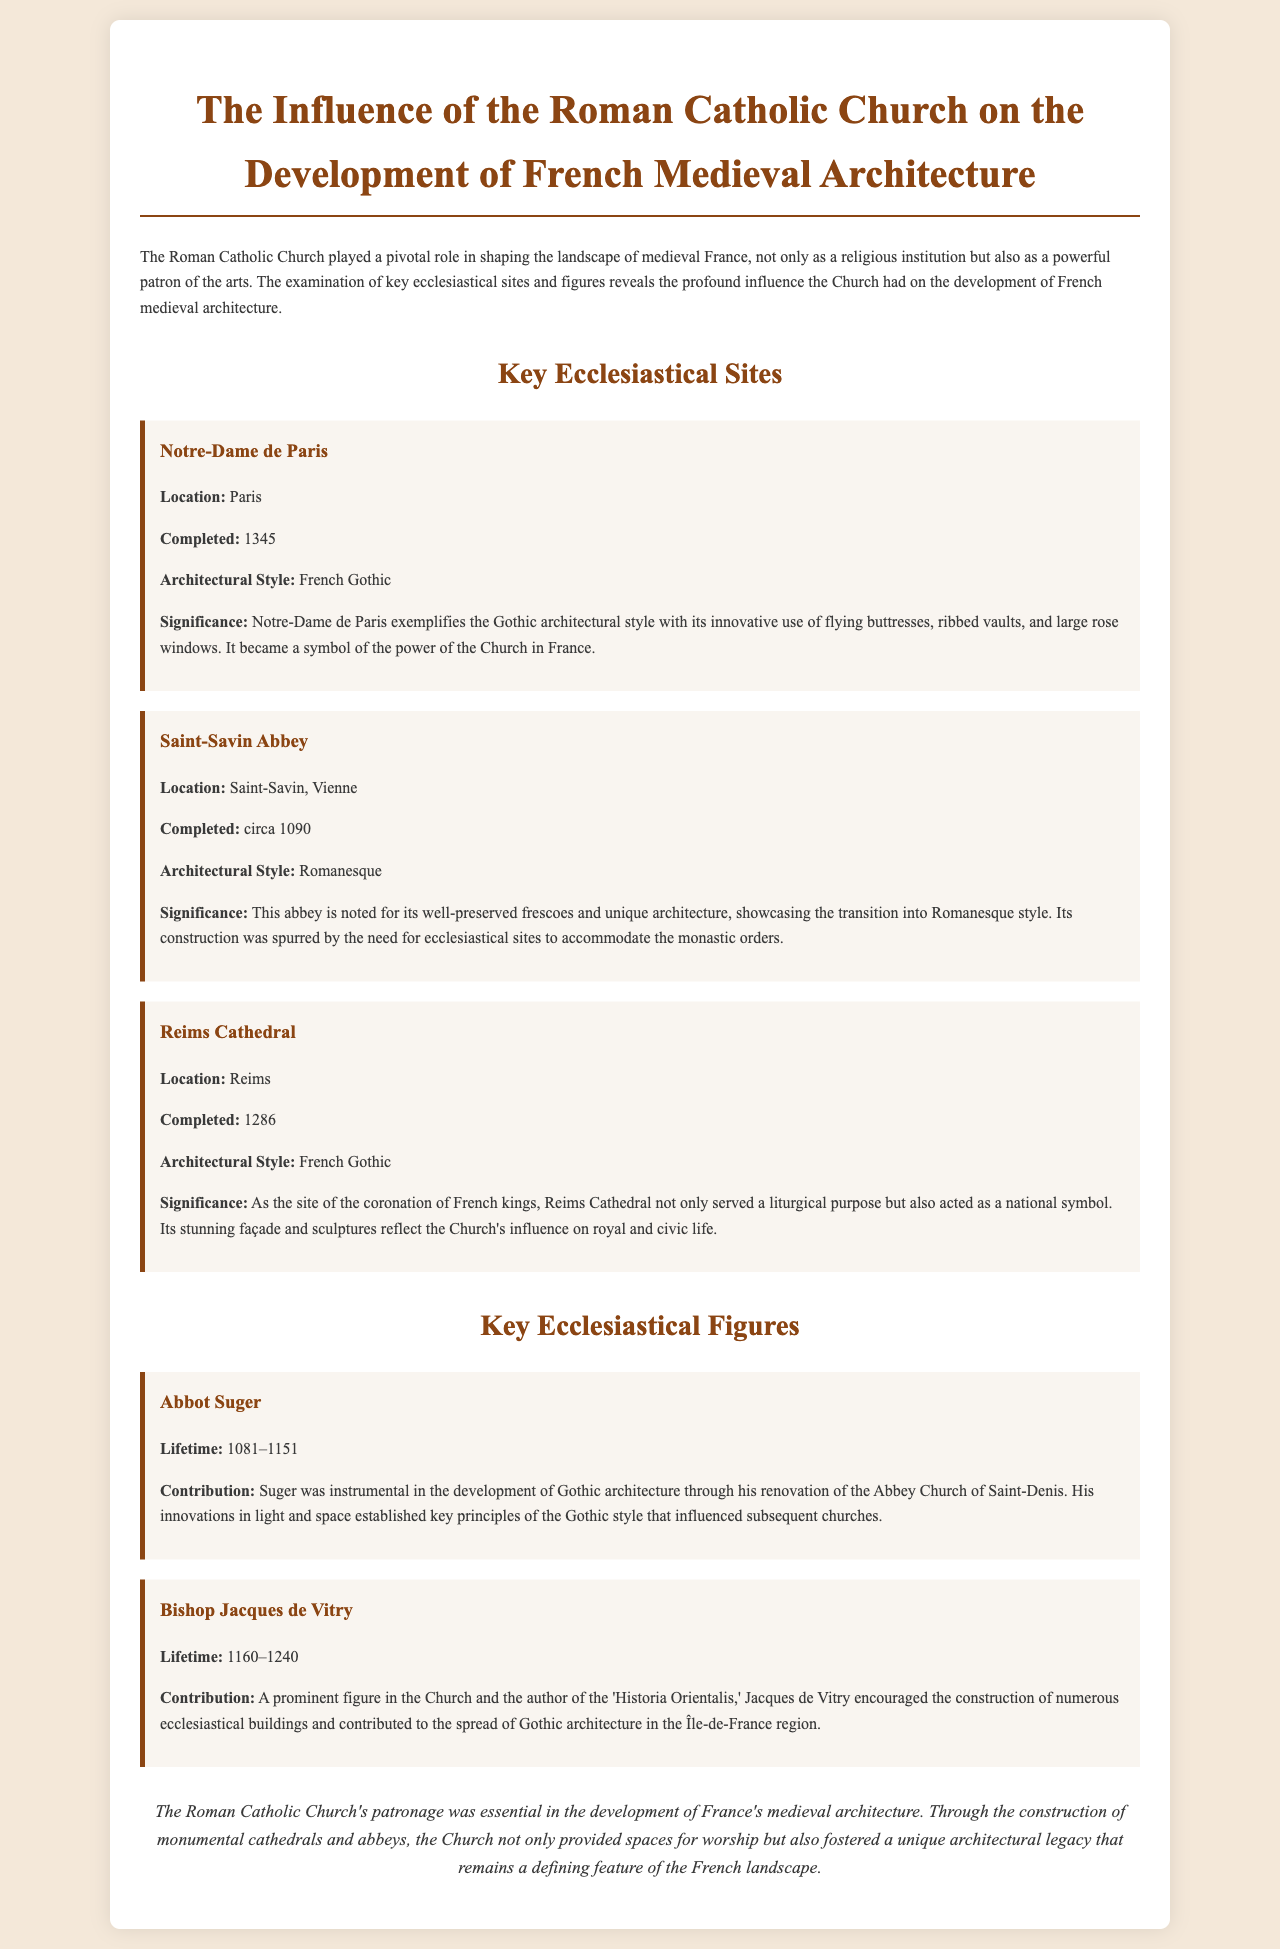What is the architectural style of Notre-Dame de Paris? Notre-Dame de Paris is noted for its architectural style, which is described as French Gothic in the document.
Answer: French Gothic Who was instrumental in the development of Gothic architecture? The document identifies Abbot Suger as a key figure who contributed significantly to the development of Gothic architecture.
Answer: Abbot Suger In what year was Reims Cathedral completed? The completion date of Reims Cathedral is explicitly stated in the document as 1286.
Answer: 1286 What is the significance of Saint-Savin Abbey? The document emphasizes that Saint-Savin Abbey is recognized for its well-preserved frescoes and unique architecture demonstrating the transition into Romanesque style.
Answer: Well-preserved frescoes What major event took place at Reims Cathedral? The document mentions that Reims Cathedral was the site of the coronation of French kings, highlighting its national significance.
Answer: Coronation of French kings What contributions did Bishop Jacques de Vitry make? According to the document, Jacques de Vitry encouraged the construction of numerous ecclesiastical buildings and spread Gothic architecture in the Île-de-France region.
Answer: Encouraged construction of ecclesiastical buildings How does the document describe the influence of the Roman Catholic Church on architecture? The document concludes that the Roman Catholic Church's patronage was essential in developing medieval architecture in France, impacting both worship and architectural legacy.
Answer: Essential patronage Where is Saint-Savin Abbey located? The document specifies the location of Saint-Savin Abbey as Saint-Savin, Vienne.
Answer: Saint-Savin, Vienne 